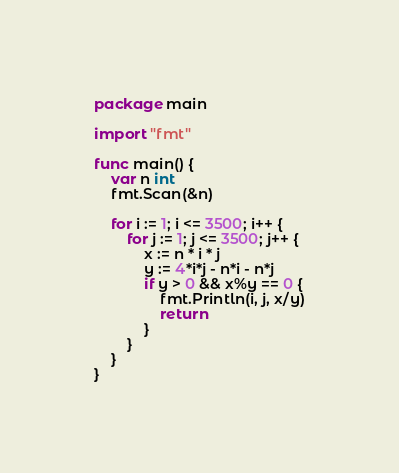Convert code to text. <code><loc_0><loc_0><loc_500><loc_500><_Go_>package main

import "fmt"

func main() {
	var n int
	fmt.Scan(&n)

	for i := 1; i <= 3500; i++ {
		for j := 1; j <= 3500; j++ {
			x := n * i * j
			y := 4*i*j - n*i - n*j
			if y > 0 && x%y == 0 {
				fmt.Println(i, j, x/y)
				return
			}
		}
	}
}
</code> 